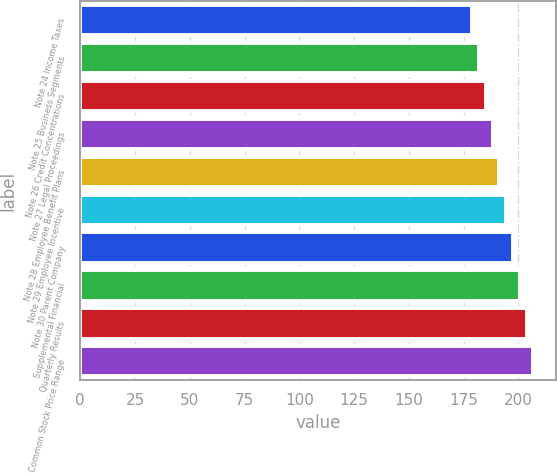<chart> <loc_0><loc_0><loc_500><loc_500><bar_chart><fcel>Note 24 Income Taxes<fcel>Note 25 Business Segments<fcel>Note 26 Credit Concentrations<fcel>Note 27 Legal Proceedings<fcel>Note 28 Employee Benefit Plans<fcel>Note 29 Employee Incentive<fcel>Note 30 Parent Company<fcel>Supplemental Financial<fcel>Quarterly Results<fcel>Common Stock Price Range<nl><fcel>179<fcel>182.1<fcel>185.2<fcel>188.3<fcel>191.4<fcel>194.5<fcel>197.6<fcel>200.7<fcel>203.8<fcel>206.9<nl></chart> 